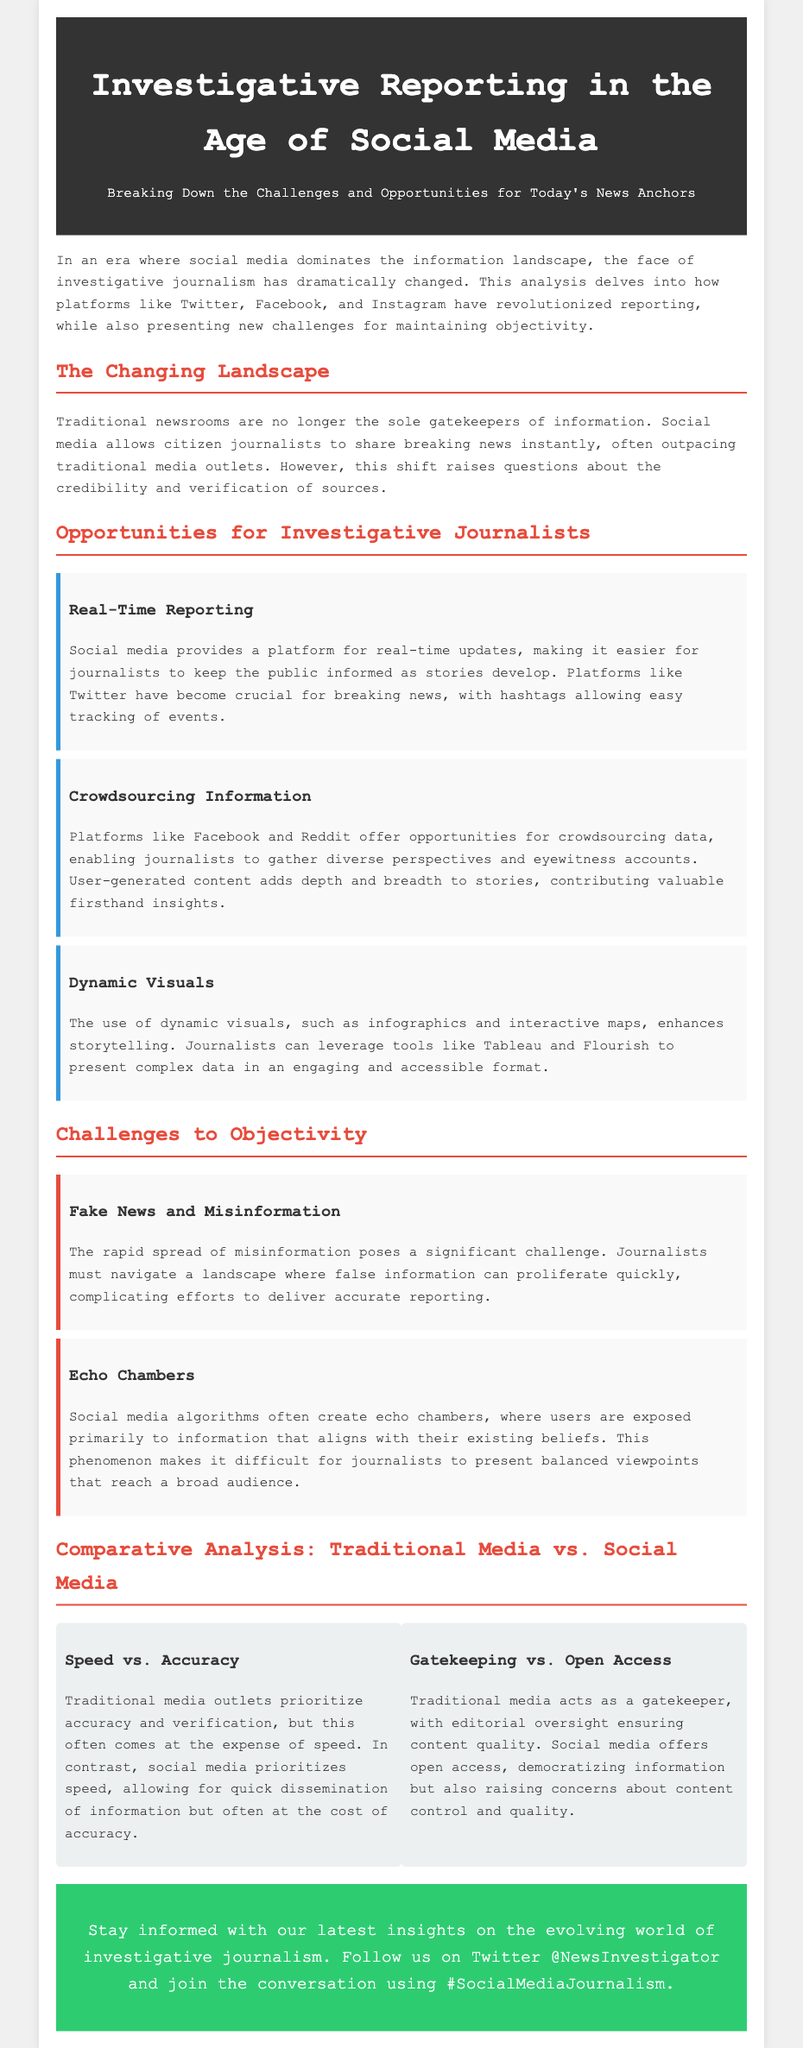what are the social media platforms mentioned? The document lists Twitter, Facebook, and Instagram as social media platforms that have influenced investigative journalism.
Answer: Twitter, Facebook, Instagram what is one opportunity for journalists mentioned in the document? The document highlights real-time reporting, crowdsourcing information, and dynamic visuals as opportunities for journalists in the age of social media.
Answer: Real-Time Reporting what challenge is posed by the rapid spread of misinformation? The document states that misinformation complicates efforts to deliver accurate reporting, making it a significant challenge for journalists.
Answer: Fake News and Misinformation which aspect does traditional media prioritize over social media? The document indicates that traditional media prioritizes accuracy, whereas social media prioritizes speed.
Answer: Accuracy what is one effect of social media algorithms mentioned? The document explains that social media algorithms can create echo chambers, where users are mainly exposed to information that aligns with their existing beliefs.
Answer: Echo Chambers how do traditional media and social media differ in terms of content control? The document describes traditional media as a gatekeeper with editorial oversight, while social media offers open access, raising concerns about content quality.
Answer: Gatekeeping vs. Open Access what should readers do to stay informed according to the advertisement? The document encourages readers to follow the organization on Twitter and join the conversation using a specific hashtag.
Answer: Follow us on Twitter @NewsInvestigator and join the conversation using #SocialMediaJournalism 